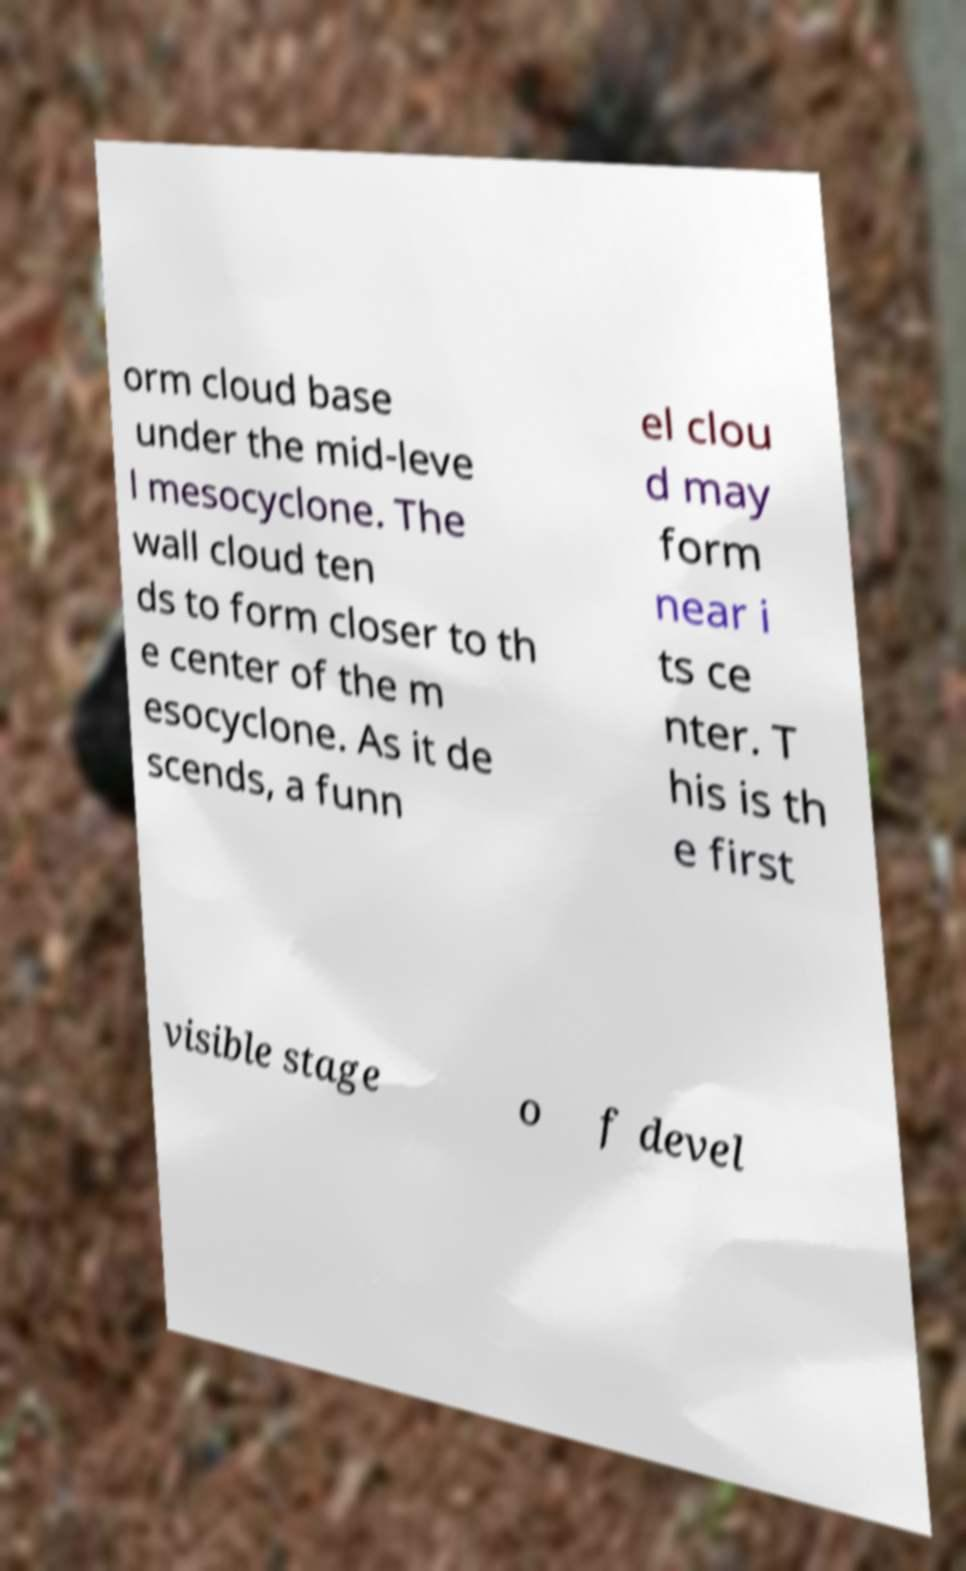Could you extract and type out the text from this image? orm cloud base under the mid-leve l mesocyclone. The wall cloud ten ds to form closer to th e center of the m esocyclone. As it de scends, a funn el clou d may form near i ts ce nter. T his is th e first visible stage o f devel 